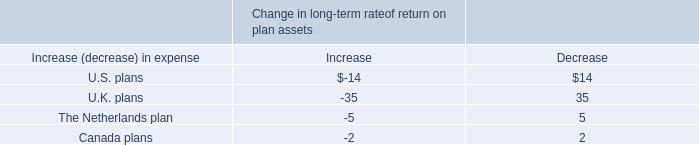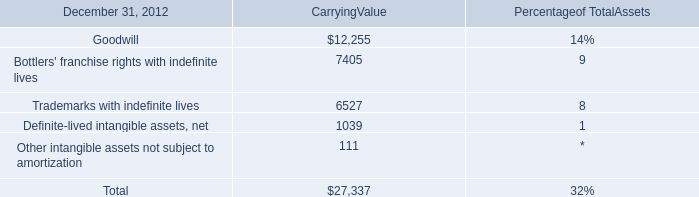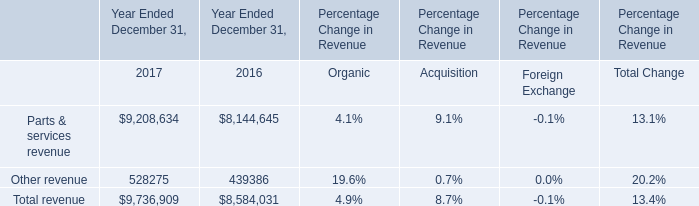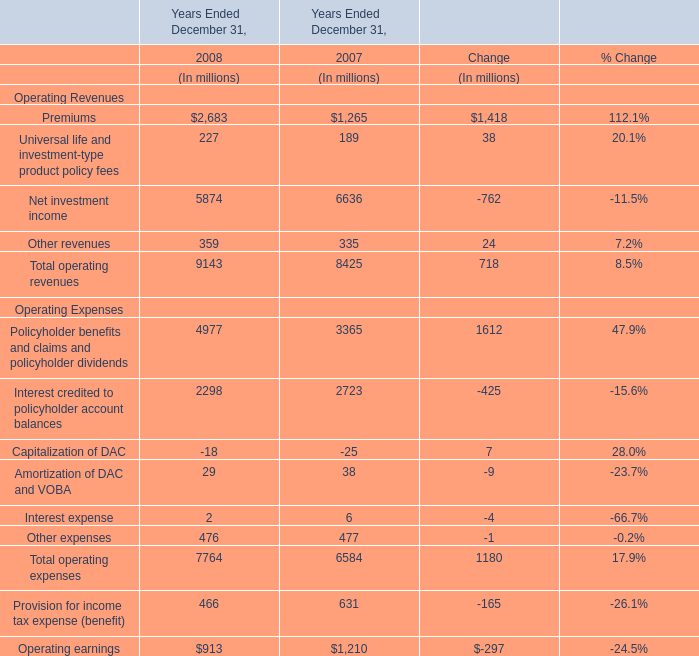In which year is the Operating earnings greater than 1000? 
Answer: 2007. 